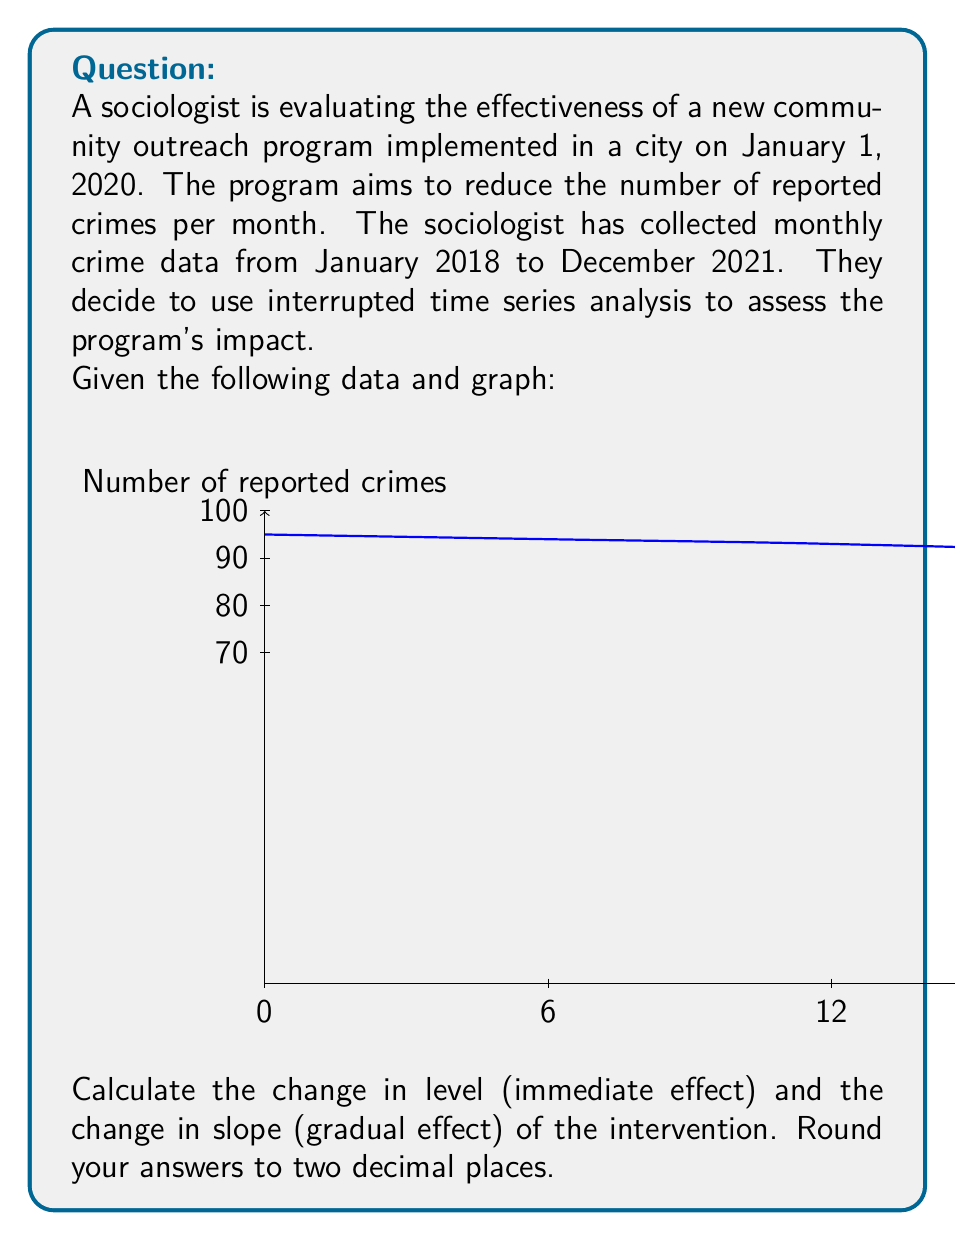Help me with this question. To evaluate the effectiveness of the social program using interrupted time series analysis, we need to calculate the change in level and change in slope. Let's approach this step-by-step:

1. Divide the time series into pre-intervention and post-intervention periods:
   - Pre-intervention: January 2018 to December 2019 (24 months)
   - Post-intervention: January 2020 to December 2021 (24 months)

2. Calculate the pre-intervention trend:
   Let $Y_t = \beta_0 + \beta_1 \cdot t + \epsilon_t$ be the pre-intervention model.
   Using linear regression on the pre-intervention data:
   $\beta_0 \approx 94.5$ (intercept)
   $\beta_1 \approx -0.05$ (slope)

3. Calculate the change in level (immediate effect):
   - Predict the value for t=24 (January 2020) using the pre-intervention model:
     $Y_{24} = 94.5 + (-0.05 \cdot 24) = 93.3$
   - Actual value at t=24: 85
   - Change in level = $85 - 93.3 = -8.3$

4. Calculate the change in slope (gradual effect):
   - Fit a new regression line to the post-intervention data:
     $Y_t = \gamma_0 + \gamma_1 \cdot t + \epsilon_t$
   - Using linear regression on the post-intervention data:
     $\gamma_0 \approx 86.5$ (intercept)
     $\gamma_1 \approx -0.45$ (slope)
   - Change in slope = $\gamma_1 - \beta_1 = -0.45 - (-0.05) = -0.40$

5. Round the results to two decimal places:
   - Change in level: -8.30
   - Change in slope: -0.40
Answer: Change in level: -8.30; Change in slope: -0.40 